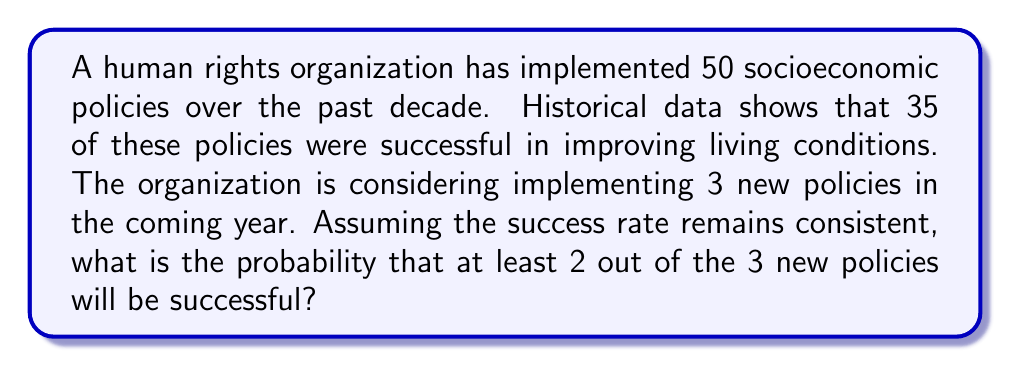Teach me how to tackle this problem. To solve this problem, we'll use the binomial probability distribution and follow these steps:

1. Calculate the probability of success for a single policy:
   $p = \frac{35}{50} = 0.7$

2. The probability of failure for a single policy:
   $q = 1 - p = 1 - 0.7 = 0.3$

3. We need to find the probability of at least 2 successes out of 3 trials. This includes the probability of 2 successes and the probability of 3 successes.

4. Using the binomial probability formula:
   $$P(X = k) = \binom{n}{k} p^k (1-p)^{n-k}$$
   where $n$ is the number of trials, $k$ is the number of successes, $p$ is the probability of success, and $q$ is the probability of failure.

5. Probability of exactly 2 successes:
   $$P(X = 2) = \binom{3}{2} (0.7)^2 (0.3)^1 = 3 \cdot 0.49 \cdot 0.3 = 0.441$$

6. Probability of exactly 3 successes:
   $$P(X = 3) = \binom{3}{3} (0.7)^3 (0.3)^0 = 1 \cdot 0.343 \cdot 1 = 0.343$$

7. Probability of at least 2 successes:
   $$P(X \geq 2) = P(X = 2) + P(X = 3) = 0.441 + 0.343 = 0.784$$

Therefore, the probability that at least 2 out of the 3 new policies will be successful is 0.784 or 78.4%.
Answer: 0.784 